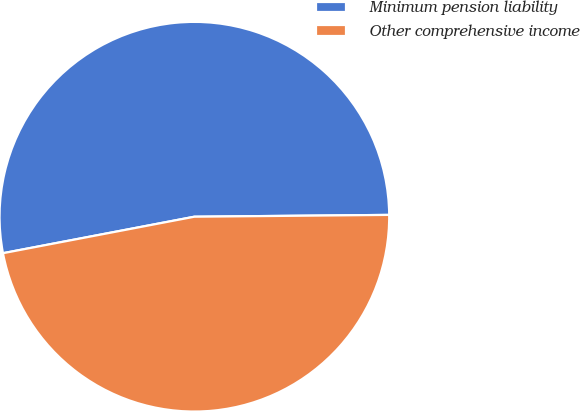Convert chart. <chart><loc_0><loc_0><loc_500><loc_500><pie_chart><fcel>Minimum pension liability<fcel>Other comprehensive income<nl><fcel>52.85%<fcel>47.15%<nl></chart> 